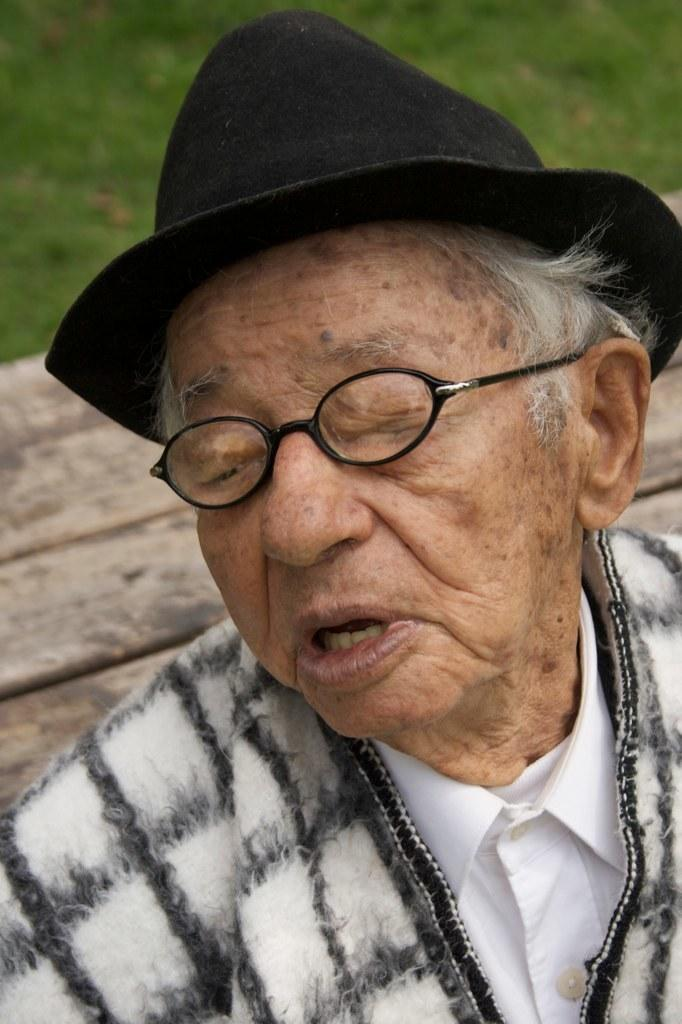What is the main subject of the image? There is a person in the middle of the image. What can be seen in the background of the image? There is grass visible behind the person. What type of hen is the person holding in the image? There is no hen present in the image; it only features a person and grass in the background. 